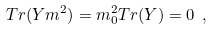Convert formula to latex. <formula><loc_0><loc_0><loc_500><loc_500>T r ( Y m ^ { 2 } ) = m ^ { 2 } _ { 0 } T r ( Y ) = 0 \ ,</formula> 